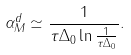Convert formula to latex. <formula><loc_0><loc_0><loc_500><loc_500>\alpha _ { M } ^ { d } \simeq \frac { 1 } { \tau \Delta _ { 0 } \ln \frac { 1 } { \tau \Delta _ { 0 } } } .</formula> 